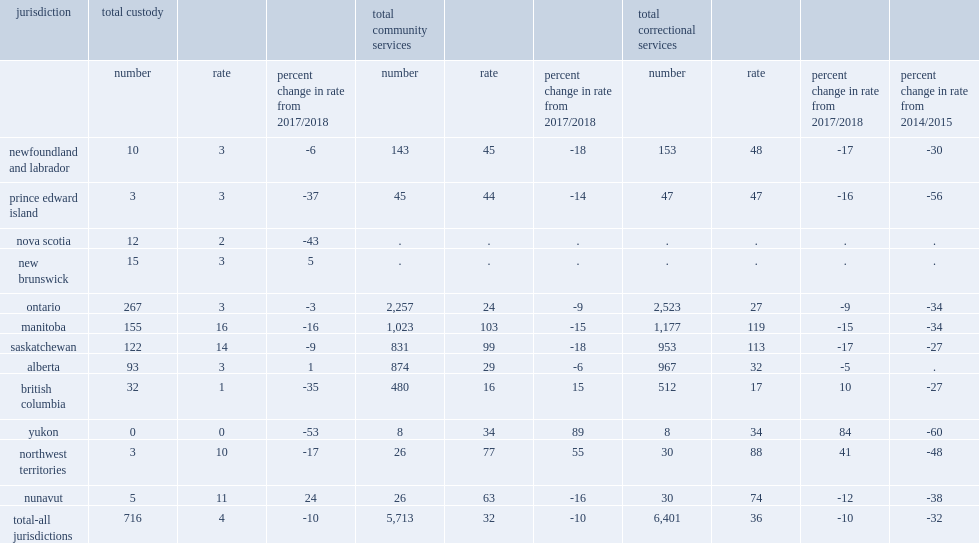In 2018/2019, how many youth in custody on average per day in the 12 reporting jurisdictions? 716.0. Among the provinces, what is the percentage of the declines in nova scotia of total custody in 2018/2019? 43. Among the provinces, what is the percentage of the declines in prince edward island of total custody in 2018/2019? 37. Among the provinces, what is the percentage of the declines in british columbia of total custody in 2018/2019? 35. In 2018/2019, what is the rate of youth incarceration in manitoba ? 16.0. In 2018/2019, what is the rate of youth incarceration in saskatchewan? 14.0. In 2018/2019, what is the rate of youth incarceration in nunavut? 11.0. In 2018/2019, what is the rate of youth incarceration in northwest territories? 10.0. In 2018/2019, on average per day,how many youth in custody or a supervised community program in the 10 reporting jurisdictions? 6401.0. In 2018/2019, what is the rate of youth in custody per 10,000 population in the 12 reporting jurisdictions? 4.0. In 2018/2019, the rate of youth in custody was 4 youth per 10,000 population in the 12 reporting jurisdictions, what is the percentage of the decrease compared to the previous year? 10. What is the rate of youth under community supervision per 10,000 population in the 10 reporting jurisdictions in 2018/2019? 32.0. The rate of youth under community supervision was 32 youth per 10,000 population in the 10 reporting jurisdictions in 2018/2019, what is the percentage of the decrease from 2017/2018? 10. What is the percentage of the decrease of newfoundland and labrador among the provinces of total correctional services in 2018/2019? 17. What is the percentage of the decrease of saskatchewan among the provinces of total correctional services in 2018/2019? 17. What is the percentage of the decrease of prince edward island among the provinces of total correctional services in 2018/2019? 16. What is the percentage of the decrease of manitoba among the provinces of total correctional services in 2018/2019? 15. Could you parse the entire table? {'header': ['jurisdiction', 'total custody', '', '', 'total community services', '', '', 'total correctional services', '', '', ''], 'rows': [['', 'number', 'rate', 'percent change in rate from 2017/2018', 'number', 'rate', 'percent change in rate from 2017/2018', 'number', 'rate', 'percent change in rate from 2017/2018', 'percent change in rate from 2014/2015'], ['newfoundland and labrador', '10', '3', '-6', '143', '45', '-18', '153', '48', '-17', '-30'], ['prince edward island', '3', '3', '-37', '45', '44', '-14', '47', '47', '-16', '-56'], ['nova scotia', '12', '2', '-43', '.', '.', '.', '.', '.', '.', '.'], ['new brunswick', '15', '3', '5', '.', '.', '.', '.', '.', '.', '.'], ['ontario', '267', '3', '-3', '2,257', '24', '-9', '2,523', '27', '-9', '-34'], ['manitoba', '155', '16', '-16', '1,023', '103', '-15', '1,177', '119', '-15', '-34'], ['saskatchewan', '122', '14', '-9', '831', '99', '-18', '953', '113', '-17', '-27'], ['alberta', '93', '3', '1', '874', '29', '-6', '967', '32', '-5', '.'], ['british columbia', '32', '1', '-35', '480', '16', '15', '512', '17', '10', '-27'], ['yukon', '0', '0', '-53', '8', '34', '89', '8', '34', '84', '-60'], ['northwest territories', '3', '10', '-17', '26', '77', '55', '30', '88', '41', '-48'], ['nunavut', '5', '11', '24', '26', '63', '-16', '30', '74', '-12', '-38'], ['total-all jurisdictions', '716', '4', '-10', '5,713', '32', '-10', '6,401', '36', '-10', '-32']]} 